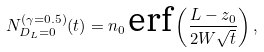Convert formula to latex. <formula><loc_0><loc_0><loc_500><loc_500>N _ { D _ { L } = 0 } ^ { ( \gamma = 0 . 5 ) } ( t ) = n _ { 0 } \, \text {erf} \left ( \frac { L - z _ { 0 } } { 2 W \sqrt { t } } \right ) ,</formula> 